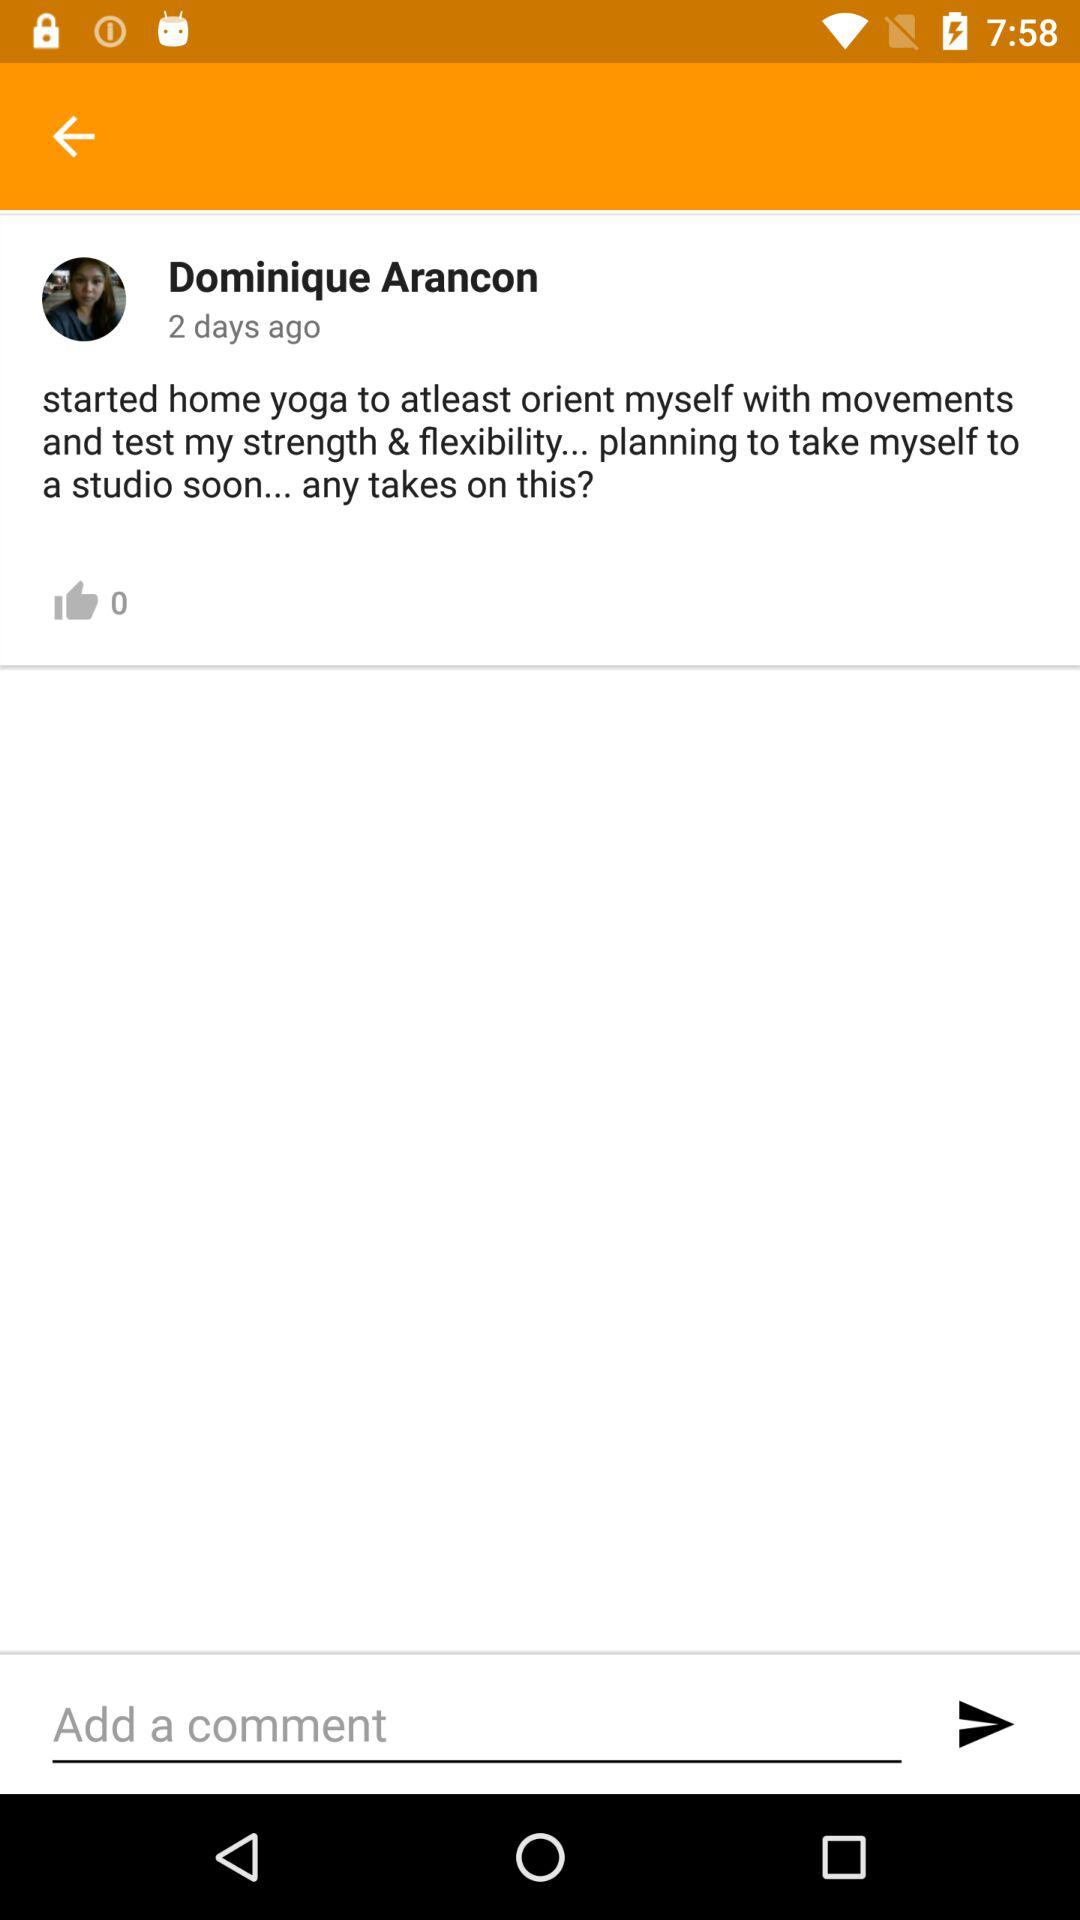How many days ago was the post posted? The post was posted two days ago. 